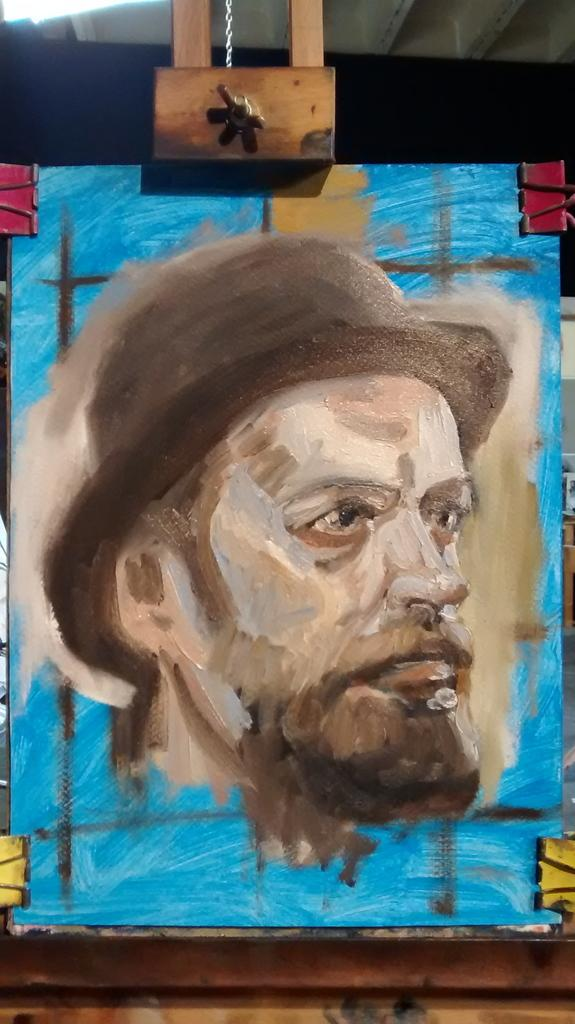What is the main subject of the painting in the image? The painting depicts a person's head with a hat. What is the board with the painting attached to? The board has clips on the sides, which may be used to attach it to something. What is the wooden object at the top of the board? The wooden object at the top of the board could be a frame or a decorative element. How many pizzas are being delivered to the person in the painting? There are no pizzas or delivery mentioned in the image or the painting. What type of bag is the person holding in the painting? There is no bag visible in the painting or the image. 